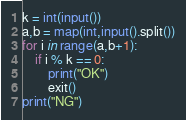<code> <loc_0><loc_0><loc_500><loc_500><_Python_>k = int(input())
a,b = map(int,input().split())
for i in range(a,b+1):
    if i % k == 0:
        print("OK")
        exit()
print("NG")</code> 